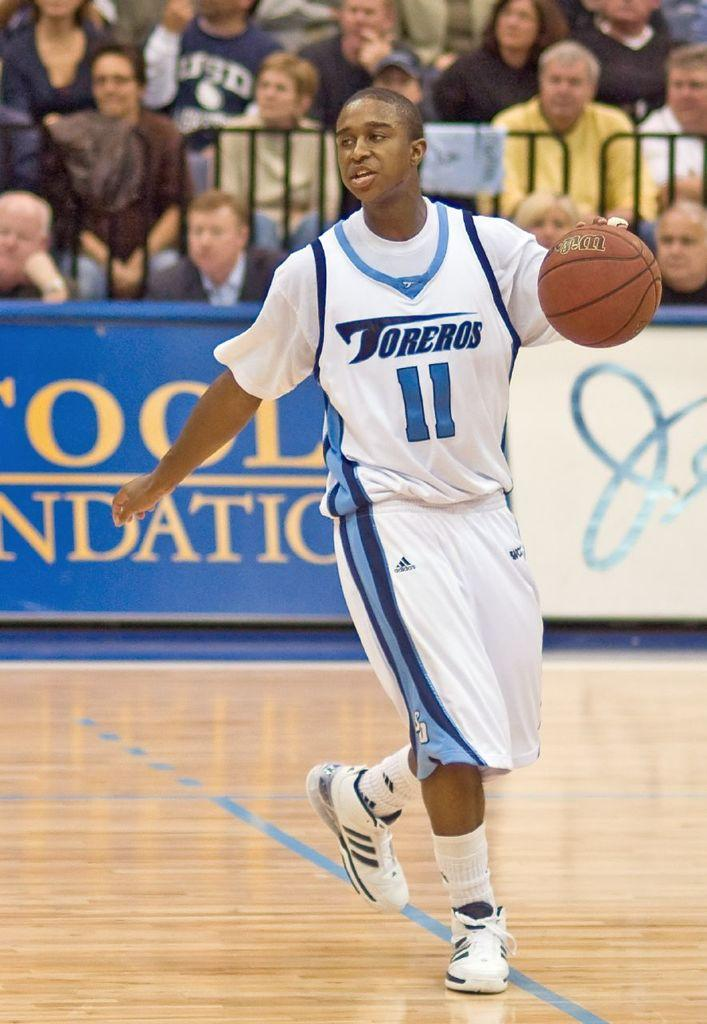Provide a one-sentence caption for the provided image. Basketball player number eleven playing for Torreros on the court. 